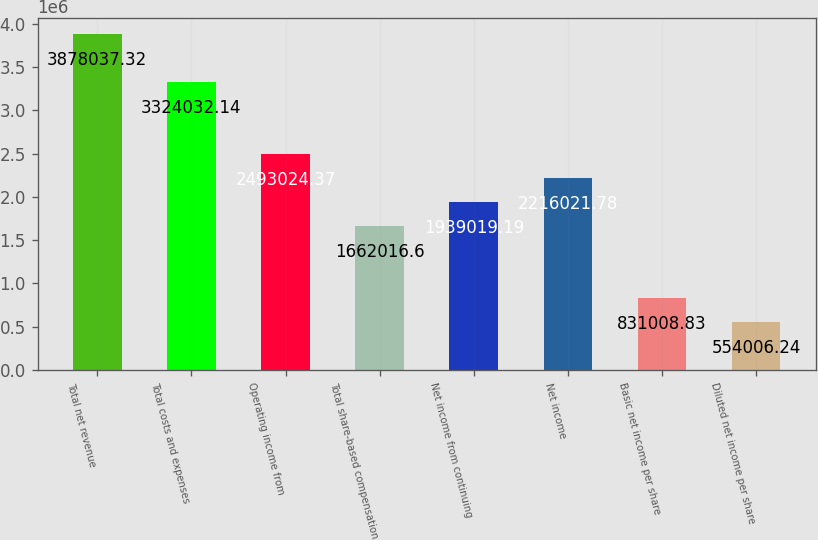Convert chart. <chart><loc_0><loc_0><loc_500><loc_500><bar_chart><fcel>Total net revenue<fcel>Total costs and expenses<fcel>Operating income from<fcel>Total share-based compensation<fcel>Net income from continuing<fcel>Net income<fcel>Basic net income per share<fcel>Diluted net income per share<nl><fcel>3.87804e+06<fcel>3.32403e+06<fcel>2.49302e+06<fcel>1.66202e+06<fcel>1.93902e+06<fcel>2.21602e+06<fcel>831009<fcel>554006<nl></chart> 